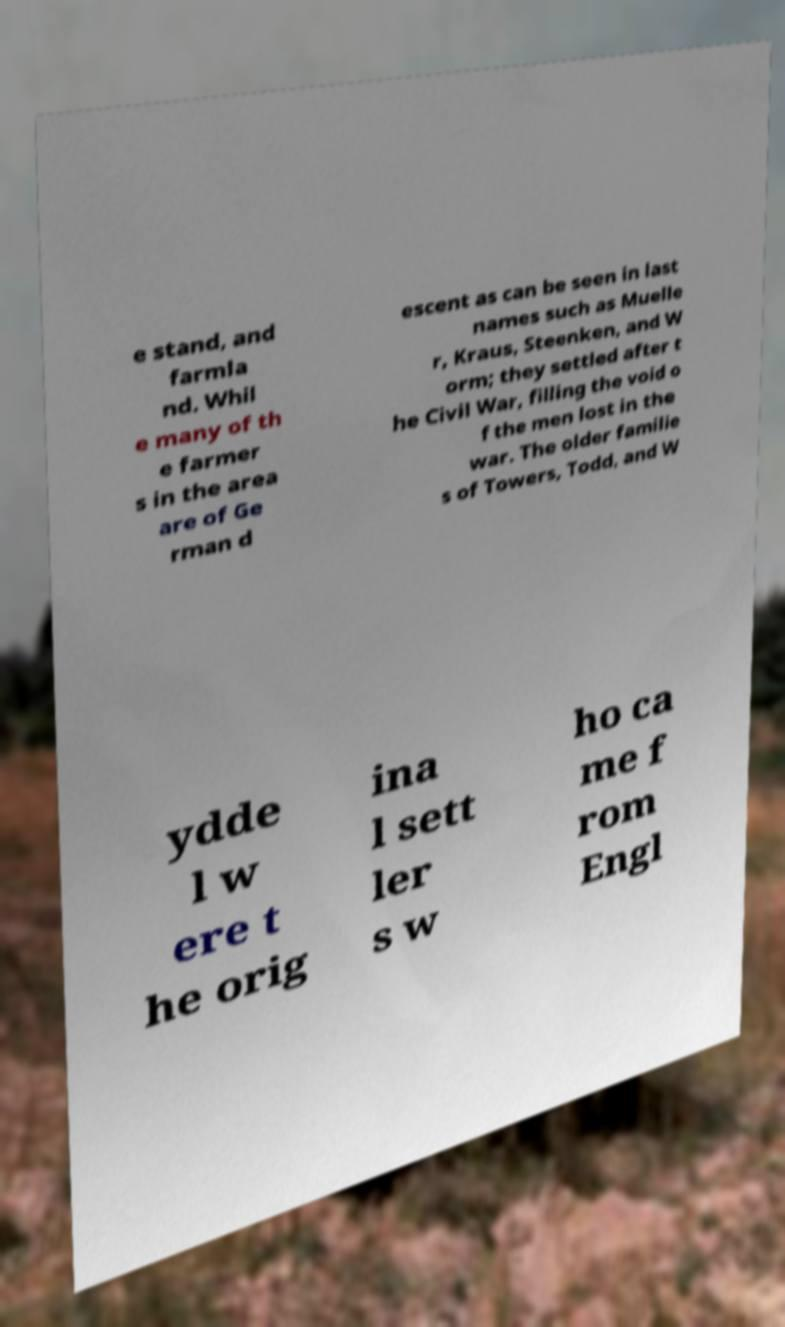Please read and relay the text visible in this image. What does it say? e stand, and farmla nd. Whil e many of th e farmer s in the area are of Ge rman d escent as can be seen in last names such as Muelle r, Kraus, Steenken, and W orm; they settled after t he Civil War, filling the void o f the men lost in the war. The older familie s of Towers, Todd, and W ydde l w ere t he orig ina l sett ler s w ho ca me f rom Engl 